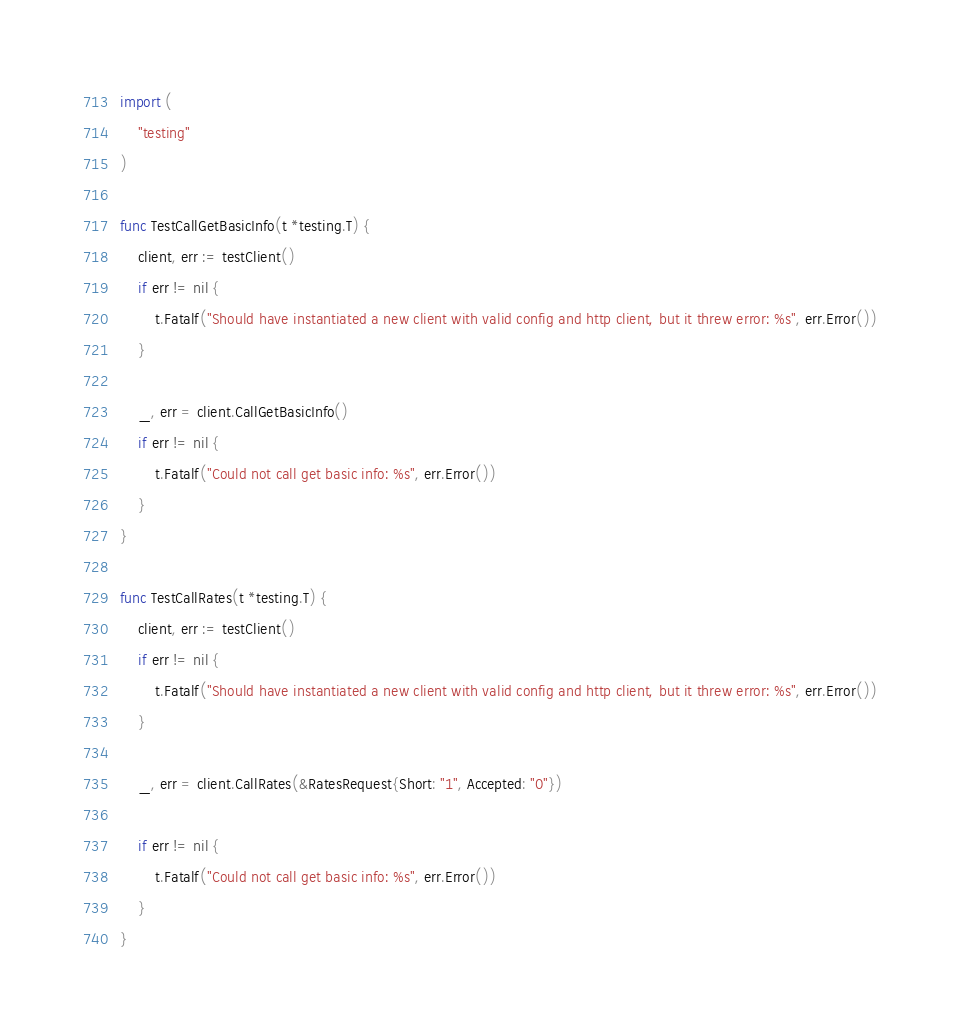Convert code to text. <code><loc_0><loc_0><loc_500><loc_500><_Go_>import (
	"testing"
)

func TestCallGetBasicInfo(t *testing.T) {
	client, err := testClient()
	if err != nil {
		t.Fatalf("Should have instantiated a new client with valid config and http client, but it threw error: %s", err.Error())
	}

	_, err = client.CallGetBasicInfo()
	if err != nil {
		t.Fatalf("Could not call get basic info: %s", err.Error())
	}
}

func TestCallRates(t *testing.T) {
	client, err := testClient()
	if err != nil {
		t.Fatalf("Should have instantiated a new client with valid config and http client, but it threw error: %s", err.Error())
	}

	_, err = client.CallRates(&RatesRequest{Short: "1", Accepted: "0"})

	if err != nil {
		t.Fatalf("Could not call get basic info: %s", err.Error())
	}
}
</code> 